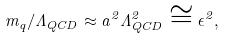Convert formula to latex. <formula><loc_0><loc_0><loc_500><loc_500>m _ { q } / \Lambda _ { Q C D } \approx a ^ { 2 } \Lambda ^ { 2 } _ { Q C D } \cong \epsilon ^ { 2 } ,</formula> 